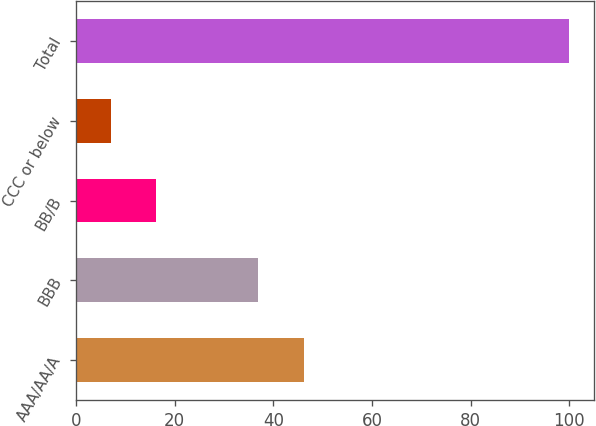Convert chart to OTSL. <chart><loc_0><loc_0><loc_500><loc_500><bar_chart><fcel>AAA/AA/A<fcel>BBB<fcel>BB/B<fcel>CCC or below<fcel>Total<nl><fcel>46.3<fcel>37<fcel>16.3<fcel>7<fcel>100<nl></chart> 